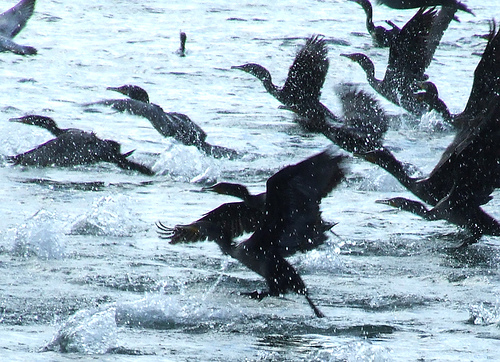Please provide a short description for this region: [0.01, 0.36, 0.31, 0.54]. The region [0.01, 0.36, 0.31, 0.54] shows 'wings level with body.' Here, we see the bird's wings stretched out, aligning with the body for streamlined flight or swimming. 